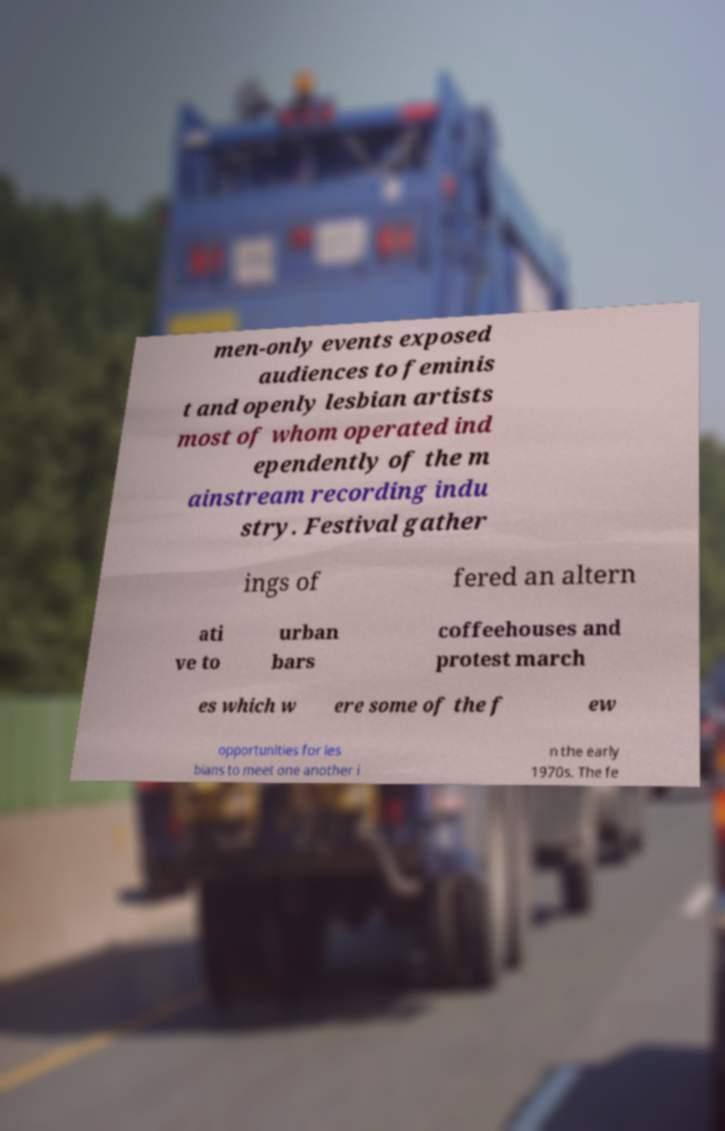What messages or text are displayed in this image? I need them in a readable, typed format. men-only events exposed audiences to feminis t and openly lesbian artists most of whom operated ind ependently of the m ainstream recording indu stry. Festival gather ings of fered an altern ati ve to urban bars coffeehouses and protest march es which w ere some of the f ew opportunities for les bians to meet one another i n the early 1970s. The fe 